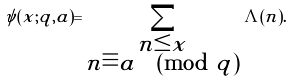<formula> <loc_0><loc_0><loc_500><loc_500>\psi ( x ; q , a ) = \sum _ { \substack { n \leq x \\ n \equiv a \pmod { q } } } \Lambda ( n ) .</formula> 